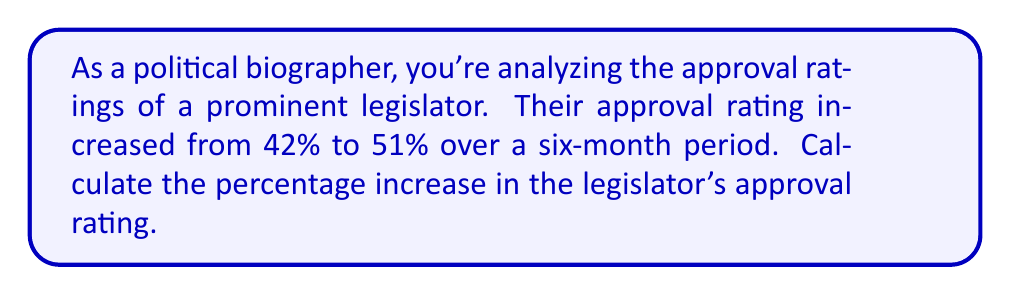Could you help me with this problem? To calculate the percentage increase in approval rating, we'll follow these steps:

1. Identify the initial and final values:
   Initial approval rating: 42%
   Final approval rating: 51%

2. Calculate the absolute increase:
   $\text{Increase} = \text{Final value} - \text{Initial value}$
   $\text{Increase} = 51\% - 42\% = 9\%$

3. Calculate the percentage increase using the formula:
   $$\text{Percentage increase} = \frac{\text{Increase}}{\text{Initial value}} \times 100\%$$

4. Plug in the values:
   $$\text{Percentage increase} = \frac{9\%}{42\%} \times 100\%$$

5. Simplify:
   $$\text{Percentage increase} = \frac{9}{42} \times 100\% = 0.2142857... \times 100\% \approx 21.43\%$$

Therefore, the legislator's approval rating increased by approximately 21.43%.
Answer: 21.43% 